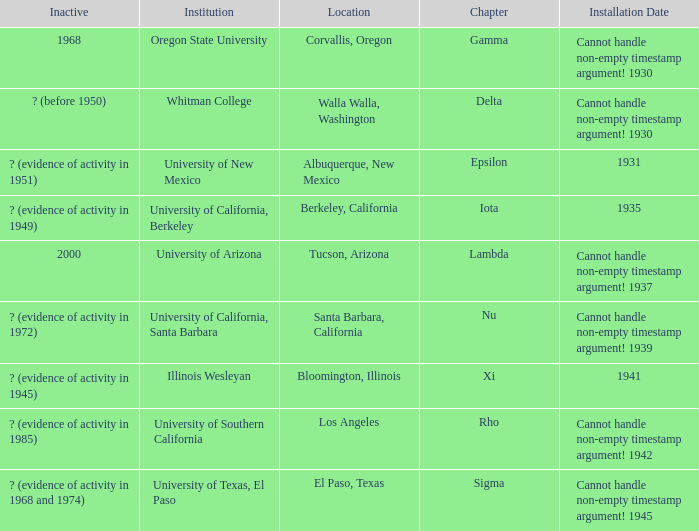What does the inactive state for University of Texas, El Paso?  ? (evidence of activity in 1968 and 1974). 